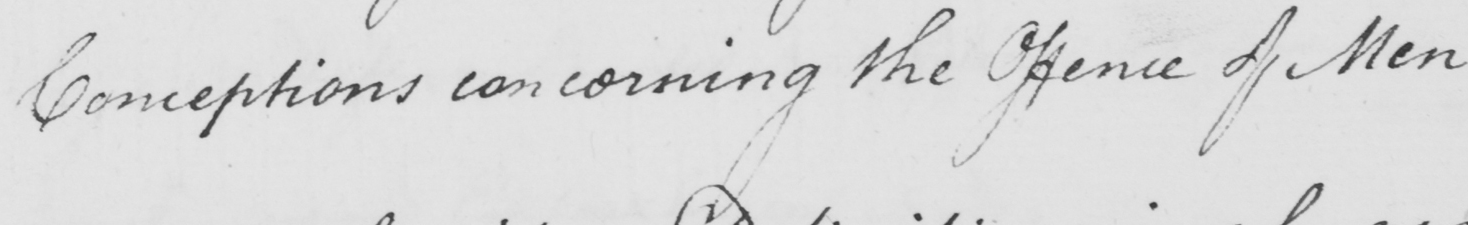Can you read and transcribe this handwriting? Conceptions concerning the Offence of Men 